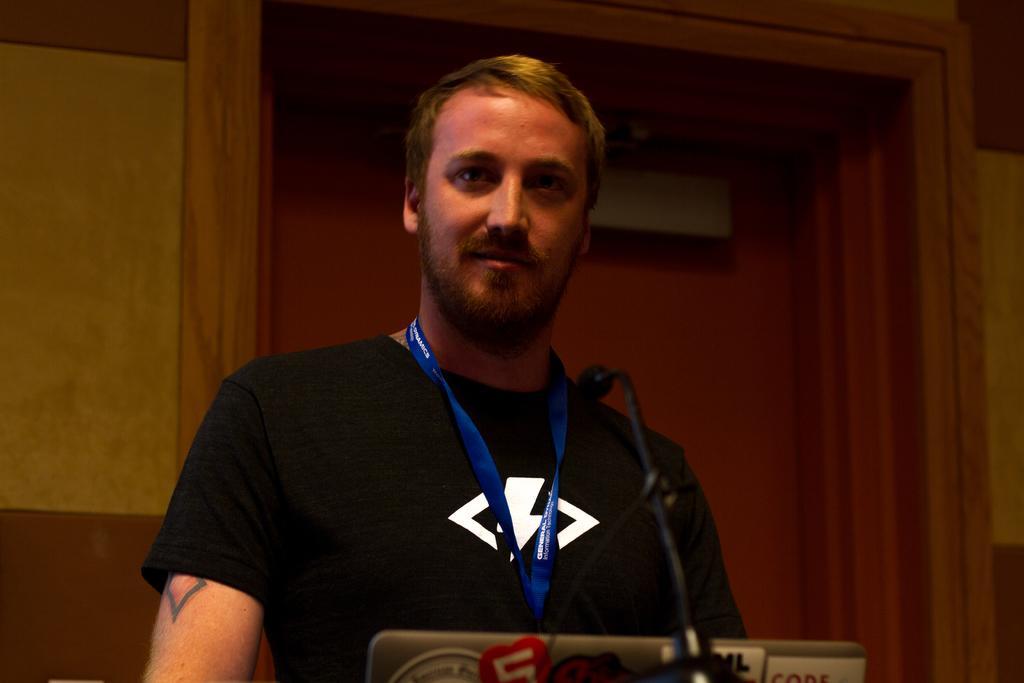How would you summarize this image in a sentence or two? In the background we can see the wall and it seems like a door. In this picture we can see a man wearing a black t-shirt and a blue tag. At the bottom portion of the picture we can see the partial part of a laptop and we can see a microphone. 